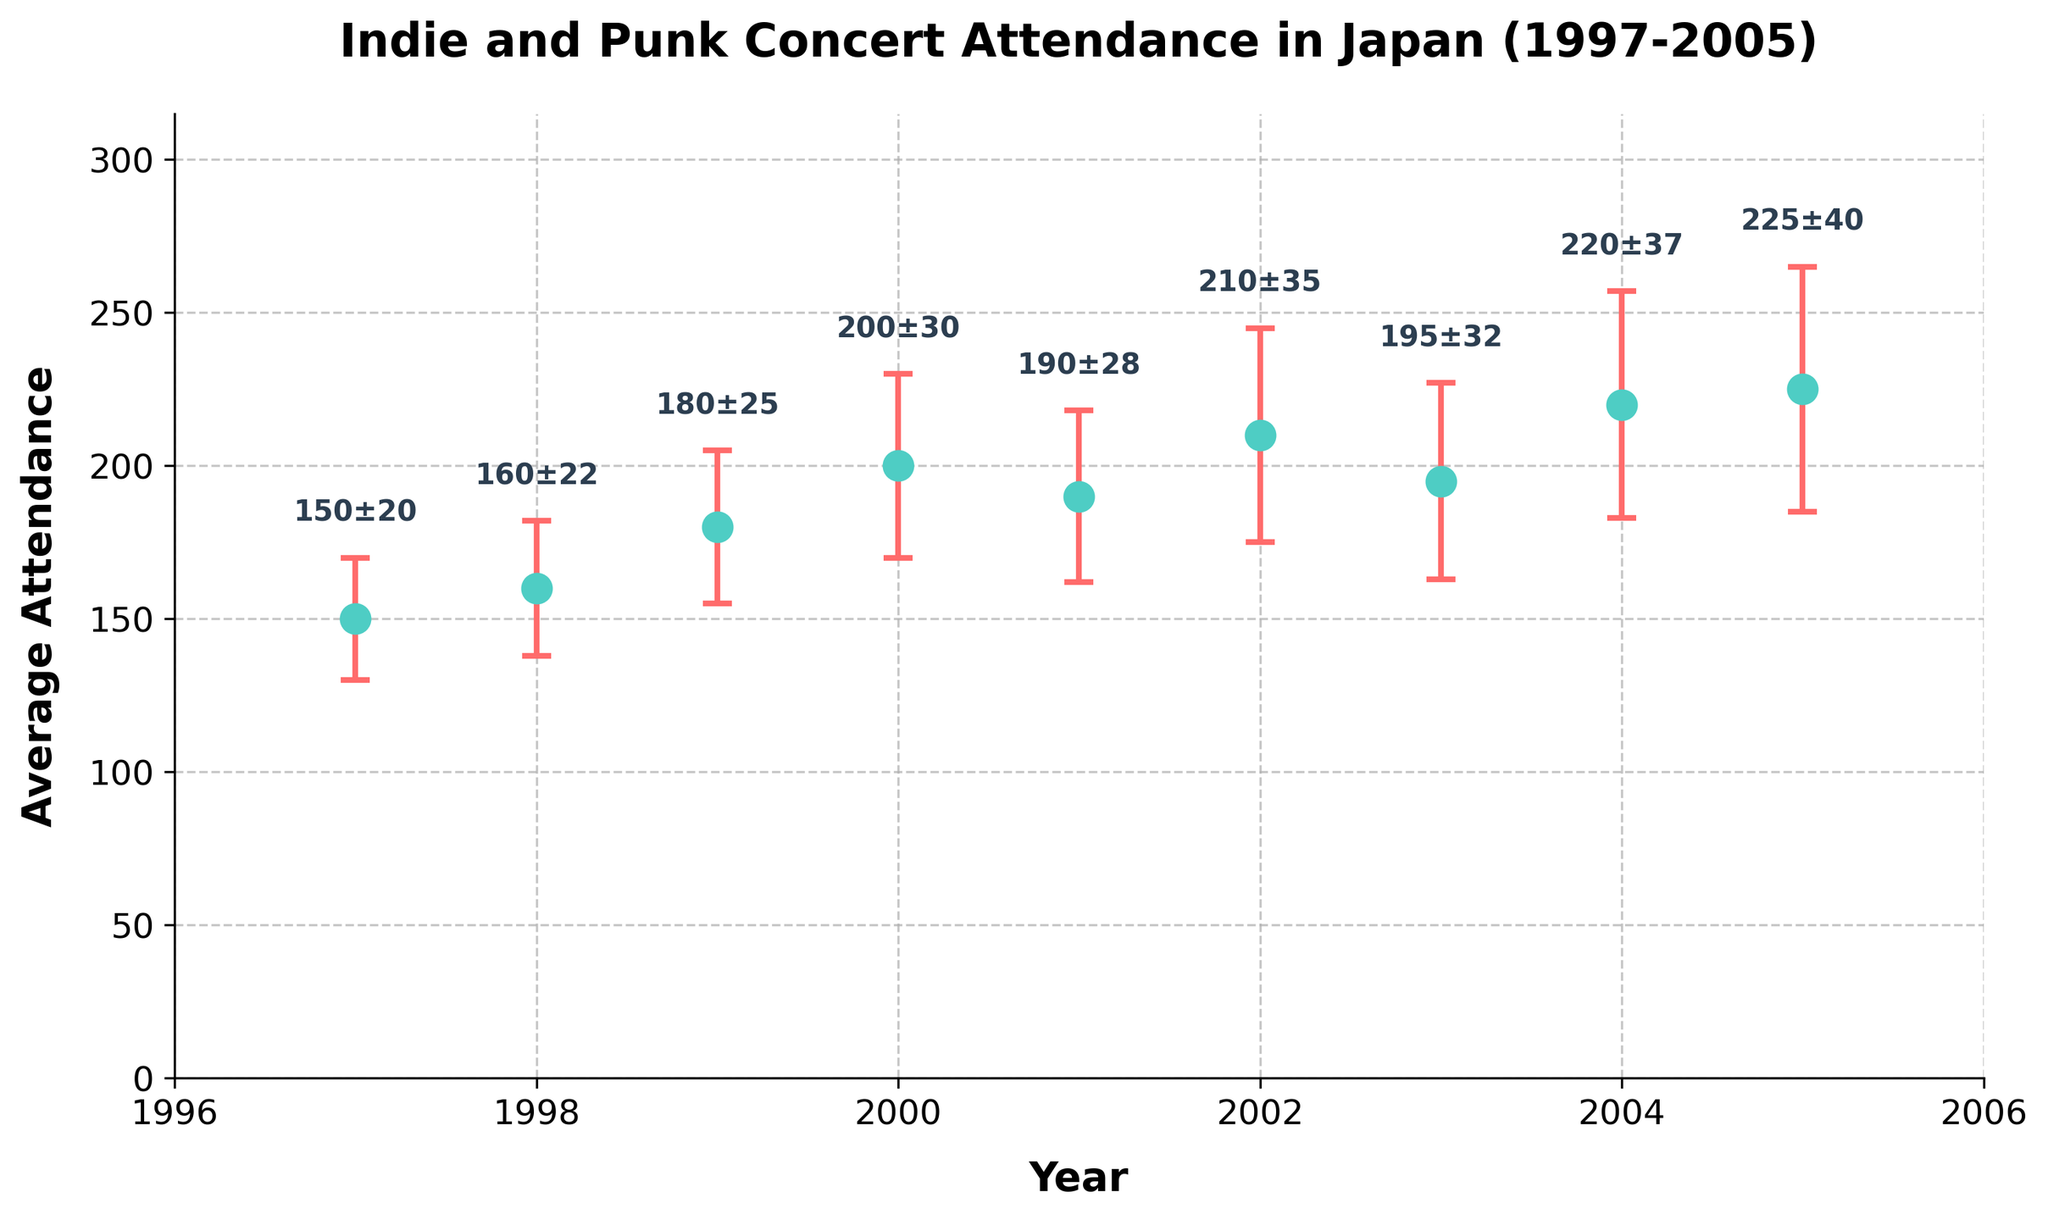What is the title of the figure? The title of the figure is usually located at the top and provides an overview of what the plot represents. In this case, it tells us it's about indie and punk concert attendance in Japan from 1997 to 2005.
Answer: Indie and Punk Concert Attendance in Japan (1997-2005) How many years are covered in the plot? We can count the distinct years shown on the x-axis or by looking at the number of data points. The years range from 1997 to 2005.
Answer: 9 years What was the average attendance in 1999? Look at the data point corresponding to the year 1999 on the x-axis and read the y-value, followed by the annotation above the error bar.
Answer: 180 Which year had the highest average attendance? Identify the highest point among all the data points on the plot. The annotations can help confirm this by showing the values.
Answer: 2005 How does the average attendance in 1997 compare to 1998? Compare the y-values for the years 1997 and 1998. Look at where the data points are on the graph and consider the annotations for the exact values. The average attendance increased from 1997 to 1998.
Answer: 1998 is higher What is the difference in average attendance between 2000 and 2003? Identify the data points for the years 2000 and 2003, read their y-values, and calculate the difference. The annotations show 2000: 200 and 2003: 195. So, the difference is 200 - 195.
Answer: 5 What was the standard deviation in attendance for the year 2002? Look at the error bar for the year 2002 and read the annotation above the data point for the exact value.
Answer: 35 In which year did the average attendance drop compared to the previous year? Examine the trend of the data points. Identify the years where the y-value is lower than the previous year's y-value. Specifically, compare each year's data point to the one before it.
Answer: 2001 and 2003 What is the overall trend in attendance from 1997 to 2005? Observe the general direction or slope of the data points from left to right. Despite some fluctuations, the general trend in average attendance is upward.
Answer: Increasing trend Which year had the largest standard deviation in attendance, and what is its value? Look at the error bars and identify the one with the highest extension. Confirm the value using the annotations above the error bars.
Answer: 2005, 40 